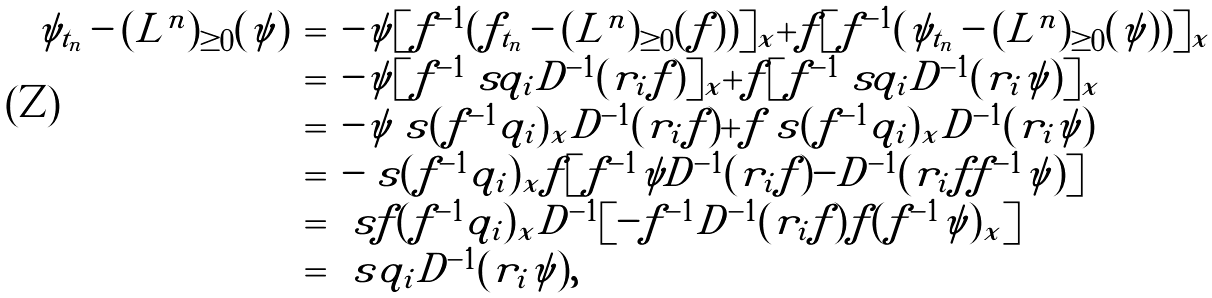<formula> <loc_0><loc_0><loc_500><loc_500>\begin{array} { l l l } \tilde { \psi } _ { t _ { n } } - ( \tilde { L } ^ { n } ) _ { \geq 0 } ( \tilde { \psi } ) & = & - \psi [ f ^ { - 1 } ( f _ { t _ { n } } - ( L ^ { n } ) _ { \geq 0 } ( f ) ) ] _ { x } + f [ f ^ { - 1 } ( \psi _ { t _ { n } } - ( L ^ { n } ) _ { \geq 0 } ( \psi ) ) ] _ { x } \\ & = & - \psi [ f ^ { - 1 } \ s q _ { i } D ^ { - 1 } ( r _ { i } f ) ] _ { x } + f [ f ^ { - 1 } \ s q _ { i } D ^ { - 1 } ( r _ { i } \psi ) ] _ { x } \\ & = & - \psi \ s ( f ^ { - 1 } q _ { i } ) _ { x } D ^ { - 1 } ( r _ { i } f ) + f \ s ( f ^ { - 1 } q _ { i } ) _ { x } D ^ { - 1 } ( r _ { i } \psi ) \\ & = & - \ s ( f ^ { - 1 } q _ { i } ) _ { x } f [ f ^ { - 1 } \psi D ^ { - 1 } ( r _ { i } f ) - D ^ { - 1 } ( r _ { i } f f ^ { - 1 } \psi ) ] \\ & = & \ s f ( f ^ { - 1 } q _ { i } ) _ { x } D ^ { - 1 } [ - f ^ { - 1 } D ^ { - 1 } ( r _ { i } f ) f ( f ^ { - 1 } \psi ) _ { x } ] \\ & = & \ s \tilde { q } _ { i } D ^ { - 1 } ( \tilde { r } _ { i } \tilde { \psi } ) , \end{array}</formula> 